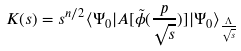Convert formula to latex. <formula><loc_0><loc_0><loc_500><loc_500>K ( s ) = s ^ { n / 2 } \langle \Psi _ { 0 } | A [ \tilde { \phi } ( \frac { p } { \sqrt { s } } ) ] | \Psi _ { 0 } \rangle _ { \frac { \Lambda } { \sqrt { s } } }</formula> 